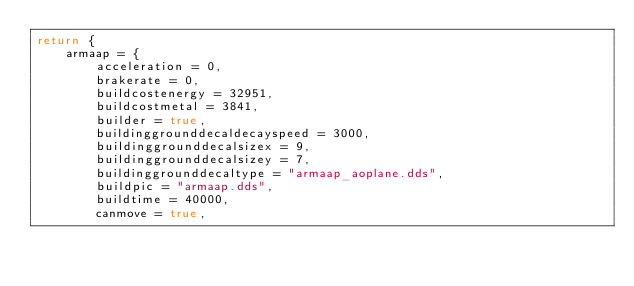<code> <loc_0><loc_0><loc_500><loc_500><_Lua_>return {
	armaap = {
		acceleration = 0,
		brakerate = 0,
		buildcostenergy = 32951,
		buildcostmetal = 3841,
		builder = true,
		buildinggrounddecaldecayspeed = 3000,
		buildinggrounddecalsizex = 9,
		buildinggrounddecalsizey = 7,
		buildinggrounddecaltype = "armaap_aoplane.dds",
		buildpic = "armaap.dds",
		buildtime = 40000,
		canmove = true,</code> 